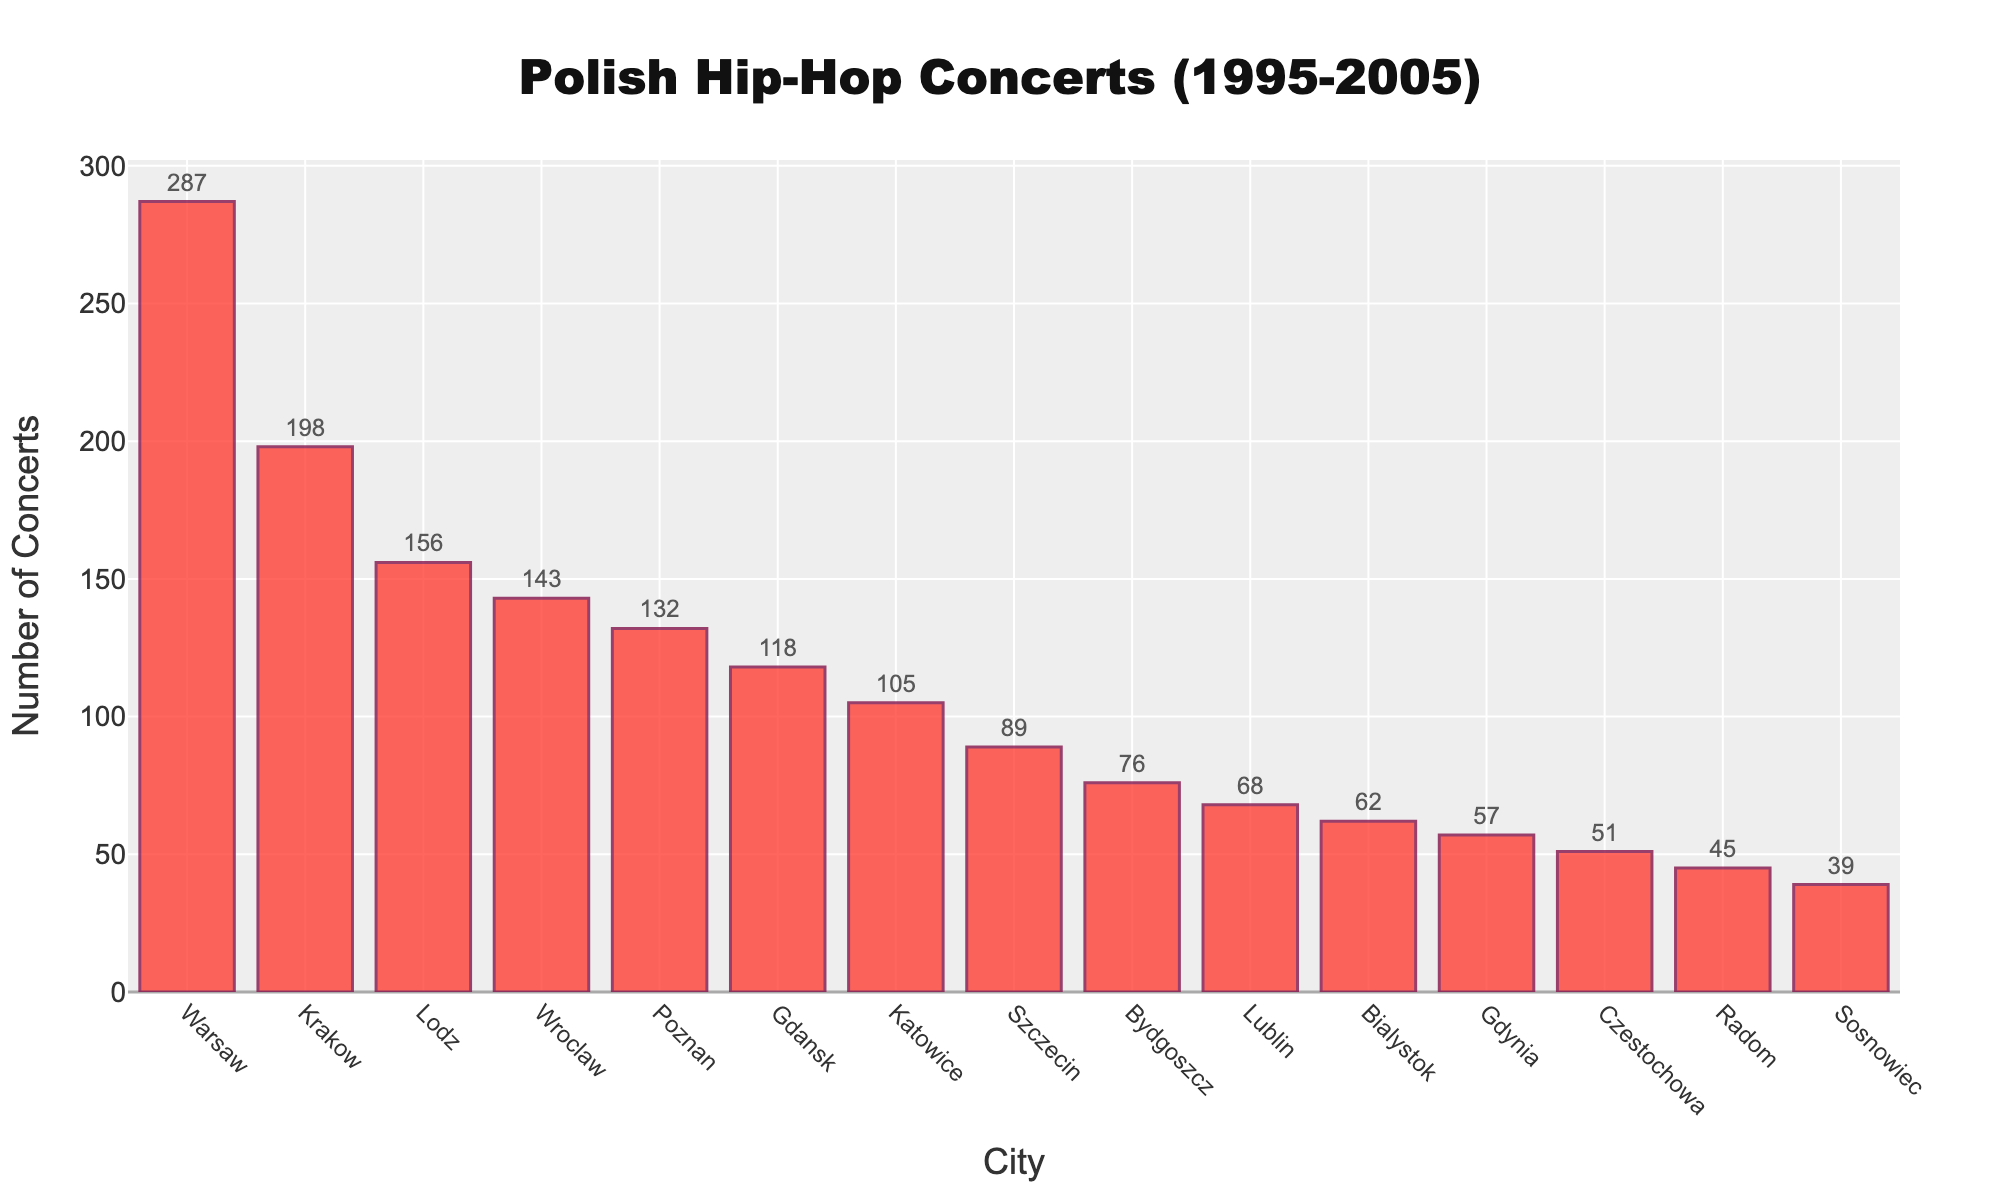Who held the most Polish hip-hop concerts between 1995 and 2005? Warsaw had the tallest bar in the chart, indicating it held the most concerts.
Answer: Warsaw Which city had fewer concerts: Gdansk or Szczecin? By comparing the heights of the bars, we see that Szczecin had a shorter bar than Gdansk.
Answer: Szczecin What’s the total number of concerts held in Warsaw and Krakow combined? Warsaw had 287 concerts and Krakow had 198; adding them gives 287 + 198 = 485.
Answer: 485 How many more concerts were held in Krakow compared to Poznan? Krakow had 198 concerts, and Poznan had 132; subtracting them gives 198 - 132 = 66.
Answer: 66 Which city ranks third in the number of hip-hop concerts held? The third tallest bar belongs to Lodz with 156 concerts.
Answer: Lodz What's the average number of concerts held in Lublin, Bialystok, and Gdynia? Adding the numbers for Lublin (68), Bialystok (62), and Gdynia (57) gives 68 + 62 + 57 = 187. Dividing by 3 gives 187/3 ≈ 62.33.
Answer: 62.33 Is the number of concerts in Wroclaw greater than in Szczecin and Radom combined? Wroclaw had 143 concerts, and the total for Szczecin (89) and Radom (45) is 89 + 45 = 134; 143 is greater than 134.
Answer: Yes Which cities had fewer than 50 concerts each? The bars for Czestochowa, Radom, and Sosnowiec are lower than the 50-mark on the y-axis.
Answer: Czestochowa, Radom, Sosnowiec Did Katowice have more than twice the number of concerts as Sosnowiec? Katowice had 105 concerts, Sosnowiec had 39; 39 * 2 = 78, and 105 is greater than 78.
Answer: Yes 